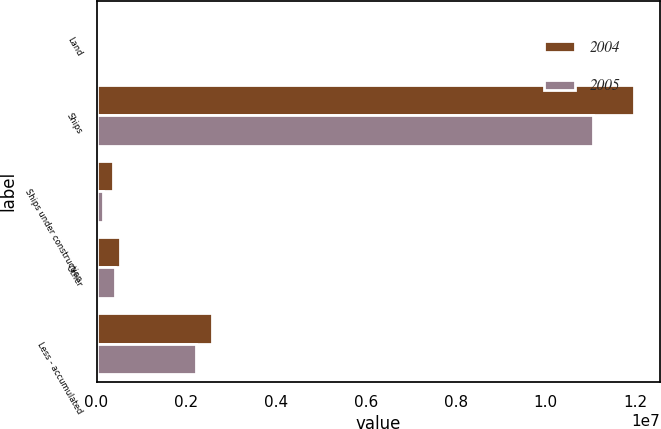Convert chart. <chart><loc_0><loc_0><loc_500><loc_500><stacked_bar_chart><ecel><fcel>Land<fcel>Ships<fcel>Ships under construction<fcel>Other<fcel>Less - accumulated<nl><fcel>2004<fcel>7056<fcel>1.19526e+07<fcel>377065<fcel>512904<fcel>2.5727e+06<nl><fcel>2005<fcel>7056<fcel>1.10569e+07<fcel>153415<fcel>415785<fcel>2.21323e+06<nl></chart> 